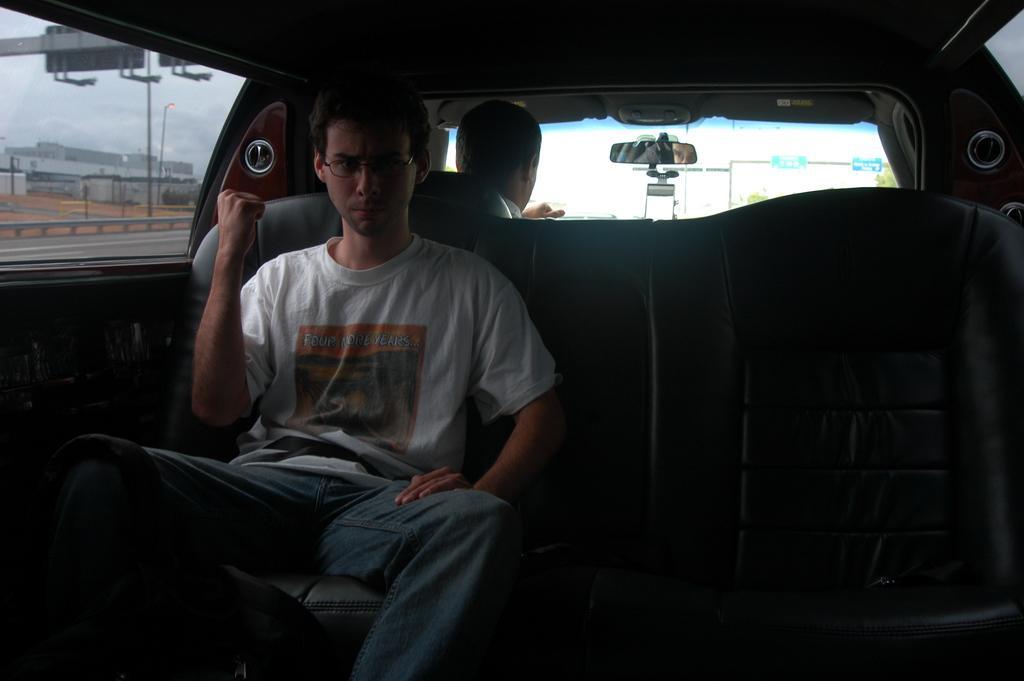Please provide a concise description of this image. In this picture we can see a man who is inside the vehicle. He has spectacles. This is road and there is a pole. On the background we can see a sky. 